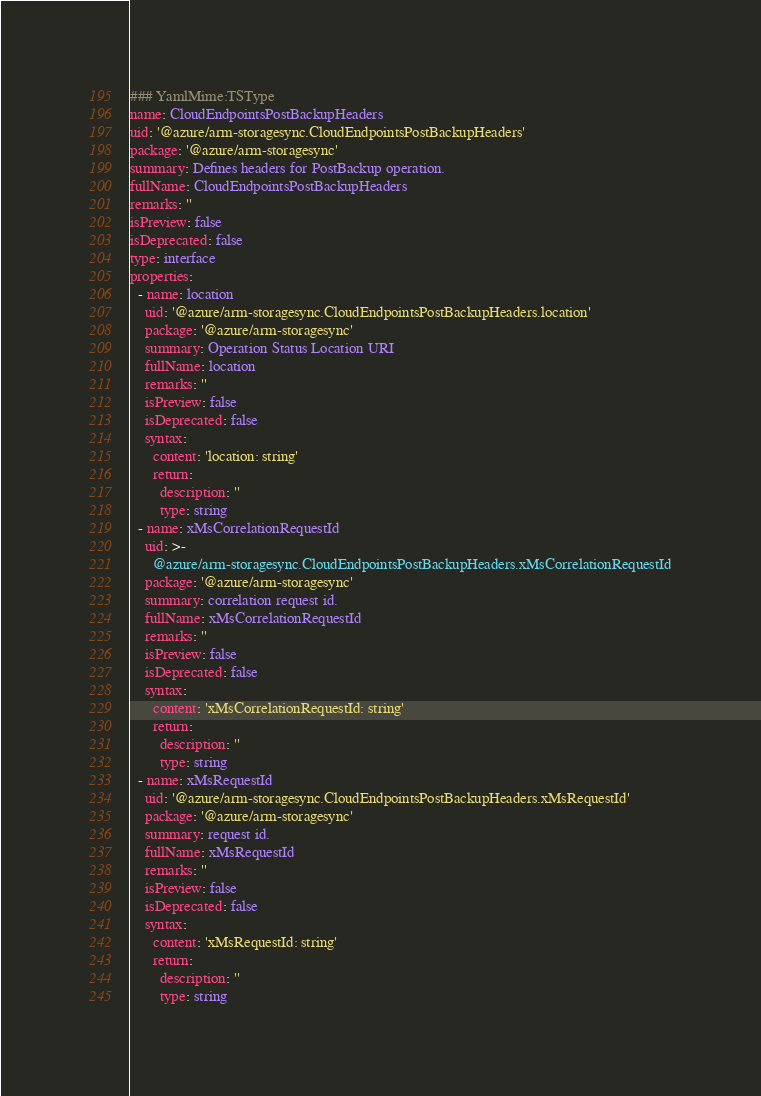Convert code to text. <code><loc_0><loc_0><loc_500><loc_500><_YAML_>### YamlMime:TSType
name: CloudEndpointsPostBackupHeaders
uid: '@azure/arm-storagesync.CloudEndpointsPostBackupHeaders'
package: '@azure/arm-storagesync'
summary: Defines headers for PostBackup operation.
fullName: CloudEndpointsPostBackupHeaders
remarks: ''
isPreview: false
isDeprecated: false
type: interface
properties:
  - name: location
    uid: '@azure/arm-storagesync.CloudEndpointsPostBackupHeaders.location'
    package: '@azure/arm-storagesync'
    summary: Operation Status Location URI
    fullName: location
    remarks: ''
    isPreview: false
    isDeprecated: false
    syntax:
      content: 'location: string'
      return:
        description: ''
        type: string
  - name: xMsCorrelationRequestId
    uid: >-
      @azure/arm-storagesync.CloudEndpointsPostBackupHeaders.xMsCorrelationRequestId
    package: '@azure/arm-storagesync'
    summary: correlation request id.
    fullName: xMsCorrelationRequestId
    remarks: ''
    isPreview: false
    isDeprecated: false
    syntax:
      content: 'xMsCorrelationRequestId: string'
      return:
        description: ''
        type: string
  - name: xMsRequestId
    uid: '@azure/arm-storagesync.CloudEndpointsPostBackupHeaders.xMsRequestId'
    package: '@azure/arm-storagesync'
    summary: request id.
    fullName: xMsRequestId
    remarks: ''
    isPreview: false
    isDeprecated: false
    syntax:
      content: 'xMsRequestId: string'
      return:
        description: ''
        type: string
</code> 